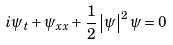Convert formula to latex. <formula><loc_0><loc_0><loc_500><loc_500>i \psi _ { t } + \psi _ { x x } + \frac { 1 } { 2 } \left | \psi \right | ^ { 2 } \psi = 0</formula> 